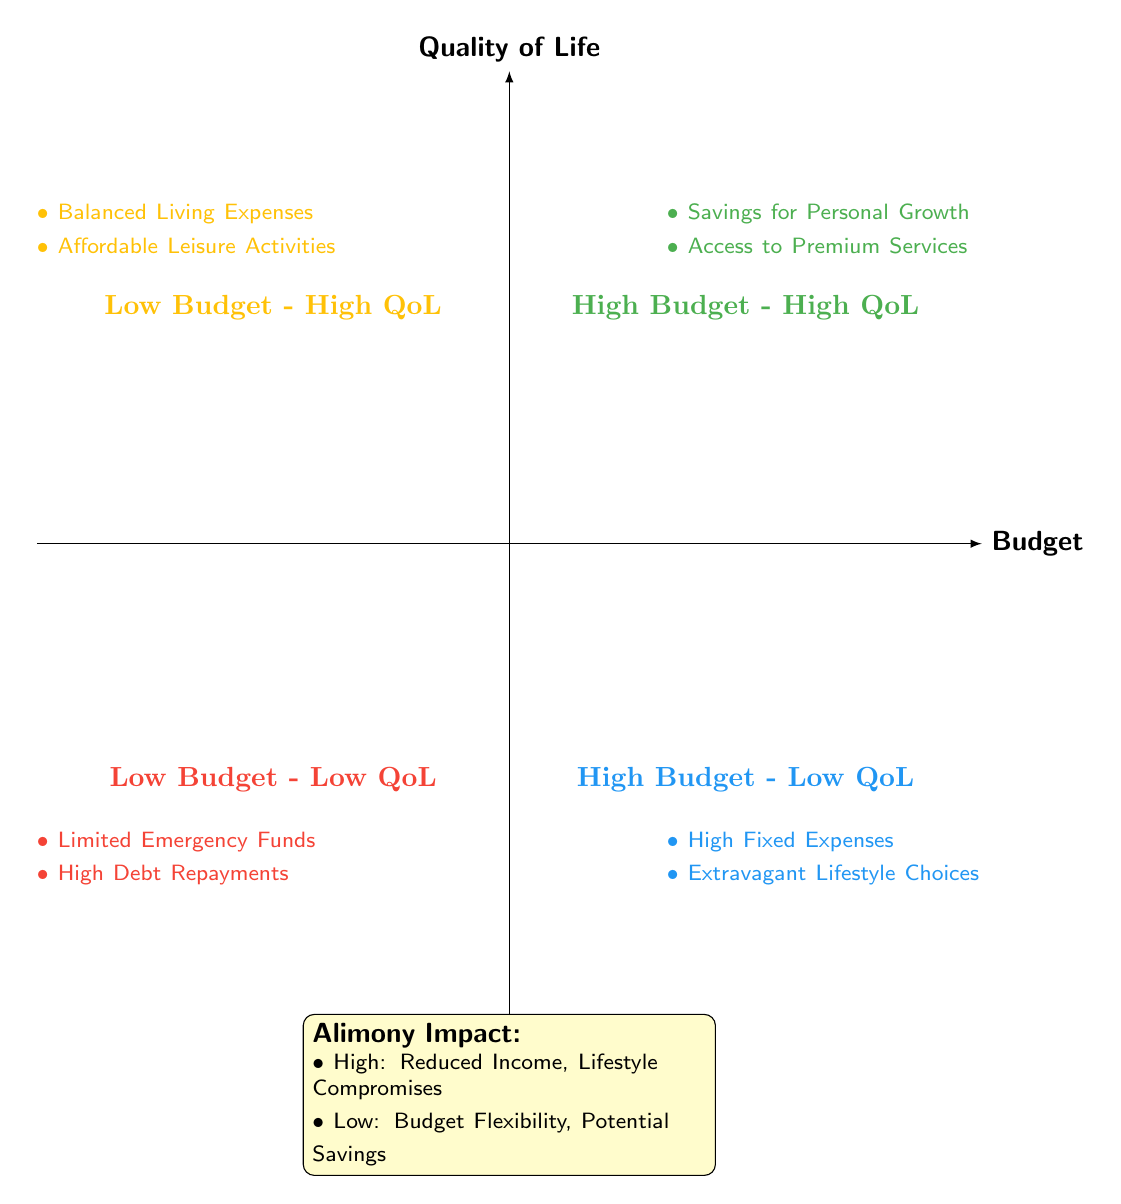What are the two components in the "High Budget - High Quality of Life" quadrant? According to the diagram, components in the "High Budget - High Quality of Life" quadrant include "Savings for Personal Growth" and "Access to Premium Services."
Answer: Savings for Personal Growth, Access to Premium Services What does high alimony payments lead to regarding disposable income? The diagram indicates that "High Alimony Payments" result in a "Significant Reduction in Disposable Income."
Answer: Significant Reduction in Disposable Income Which quadrant represents "High Fixed Expenses" and "Extravagant Lifestyle Choices"? The diagram shows that "High Fixed Expenses" and "Extravagant Lifestyle Choices" are located in the "High Budget - Low Quality of Life" quadrant.
Answer: High Budget - Low Quality of Life How many total components are there in the "Low Budget - High Quality of Life" quadrant? Within the "Low Budget - High Quality of Life" quadrant, there are two components: "Balanced Living Expenses" and "Affordable Leisure Activities." Thus, the total is two.
Answer: 2 What flexibility does a low alimony payment provide? The diagram states that "Low Alimony Payments" allow for "More Flexibility in Budget Allocation" and "Potential Savings for Future Investments."
Answer: More Flexibility in Budget Allocation Which quadrant is associated with "Limited Emergency Funds"? The diagram clearly associates "Limited Emergency Funds" with the "Low Budget - Low Quality of Life" quadrant.
Answer: Low Budget - Low Quality of Life What is the overall impact of high alimony payments? High alimony payments lead to "Reduced Income" and "Lifestyle Compromises," as indicated in the diagram.
Answer: Reduced Income, Lifestyle Compromises In which quadrant can one find "Affordable Leisure Activities"? According to the diagram, "Affordable Leisure Activities" are found in the "Low Budget - High Quality of Life" quadrant.
Answer: Low Budget - High Quality of Life 